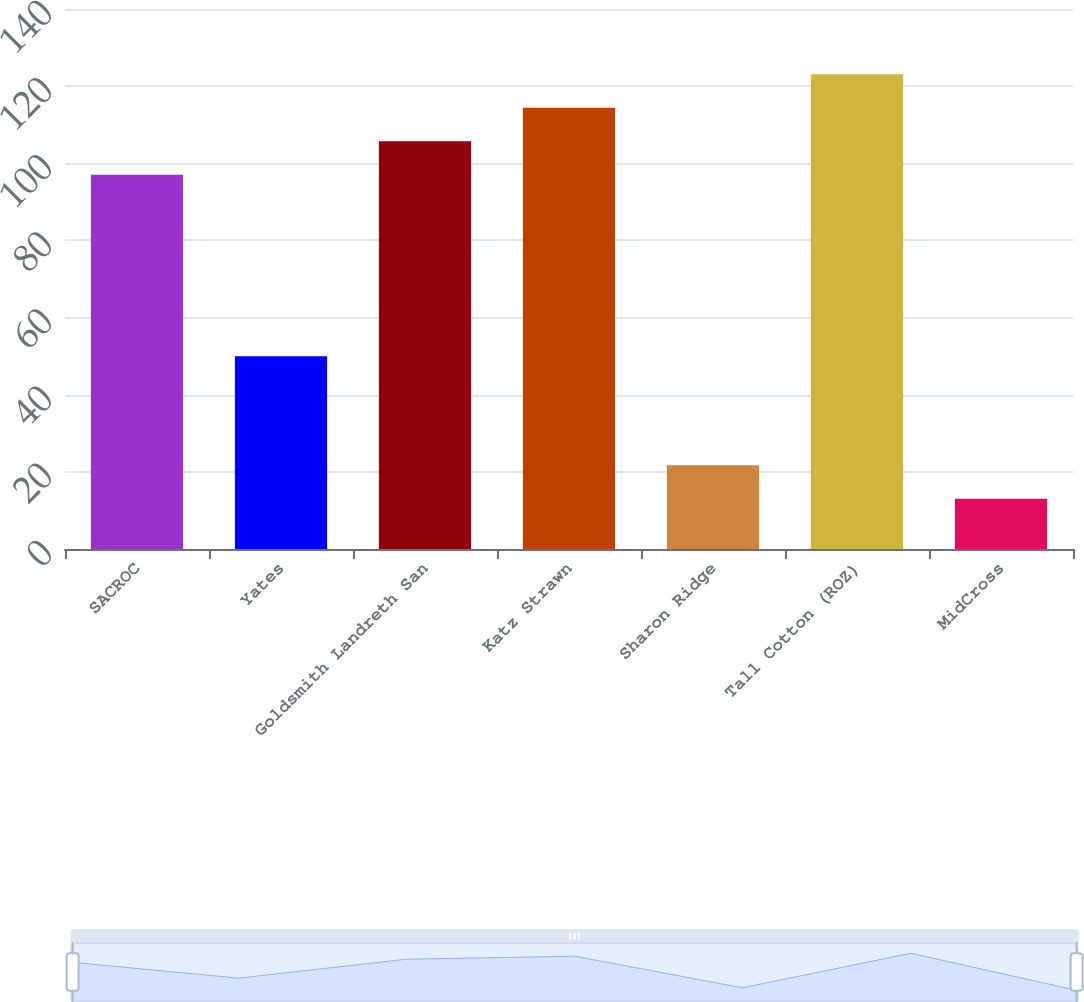<chart> <loc_0><loc_0><loc_500><loc_500><bar_chart><fcel>SACROC<fcel>Yates<fcel>Goldsmith Landreth San<fcel>Katz Strawn<fcel>Sharon Ridge<fcel>Tall Cotton (ROZ)<fcel>MidCross<nl><fcel>97<fcel>50<fcel>105.7<fcel>114.4<fcel>21.7<fcel>123.1<fcel>13<nl></chart> 